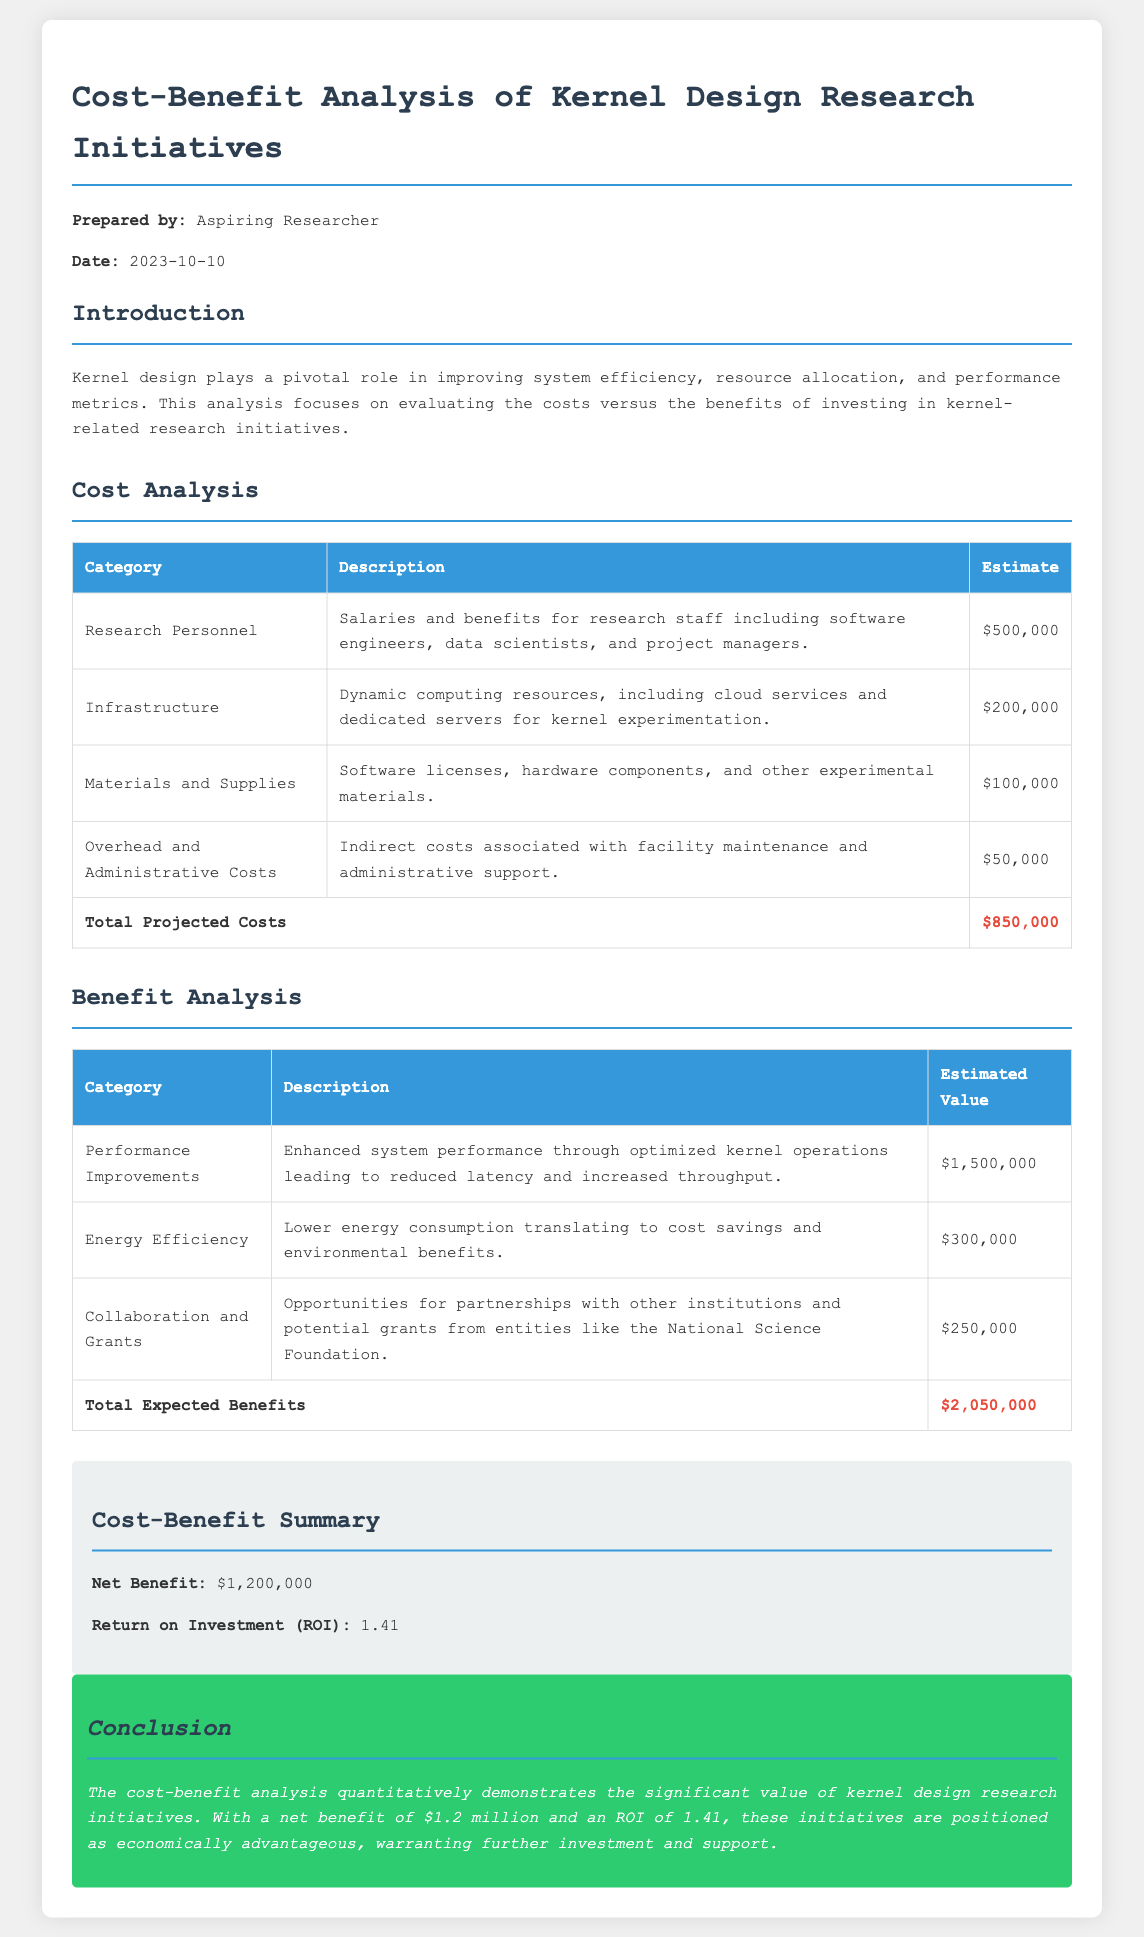What are the total projected costs? The total projected costs are summarized in the cost analysis section as $850,000.
Answer: $850,000 What is the estimated value of performance improvements? The estimated value for performance improvements is listed in the benefit analysis as $1,500,000.
Answer: $1,500,000 What is the net benefit from the analysis? The net benefit is calculated in the cost-benefit summary section as the difference between total expected benefits and total projected costs, which is $1,200,000.
Answer: $1,200,000 What is the total expected benefits? The total expected benefits from the benefit analysis section are summarized as $2,050,000.
Answer: $2,050,000 What is the ROI of the kernel design research initiatives? The Return on Investment (ROI) is calculated in the cost-benefit summary as 1.41.
Answer: 1.41 How much is allocated to infrastructure? The cost analysis section shows that $200,000 is allocated to infrastructure for kernel experimentation.
Answer: $200,000 What organization is mentioned as a potential grant source? The National Science Foundation is mentioned as a potential grant source in the benefit analysis.
Answer: National Science Foundation What is the date of the report? The report date is mentioned at the beginning as 2023-10-10.
Answer: 2023-10-10 What type of costs are included under "Materials and Supplies"? Materials and Supplies include software licenses, hardware components, and other experimental materials, as described in the cost analysis section.
Answer: Software licenses, hardware components, and other experimental materials 